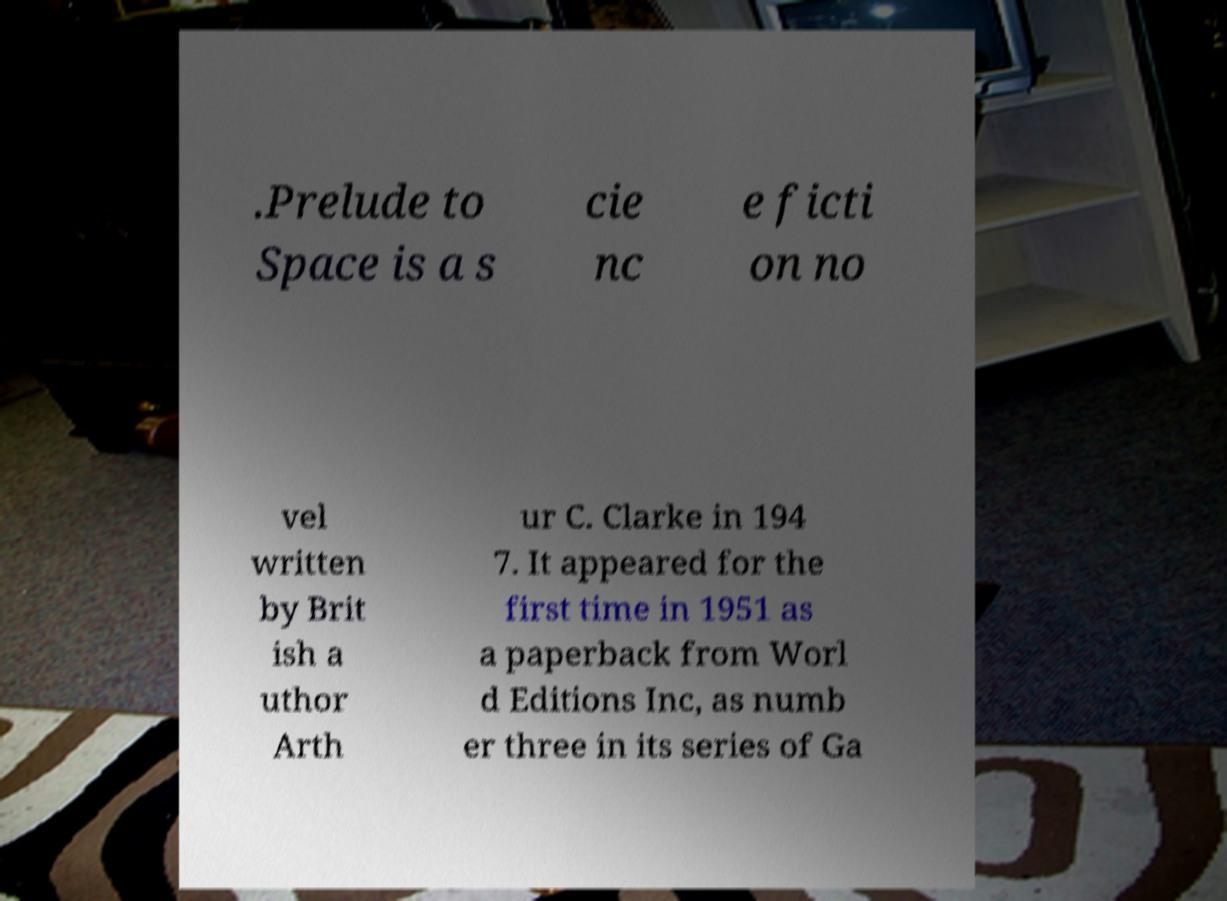Could you assist in decoding the text presented in this image and type it out clearly? .Prelude to Space is a s cie nc e ficti on no vel written by Brit ish a uthor Arth ur C. Clarke in 194 7. It appeared for the first time in 1951 as a paperback from Worl d Editions Inc, as numb er three in its series of Ga 